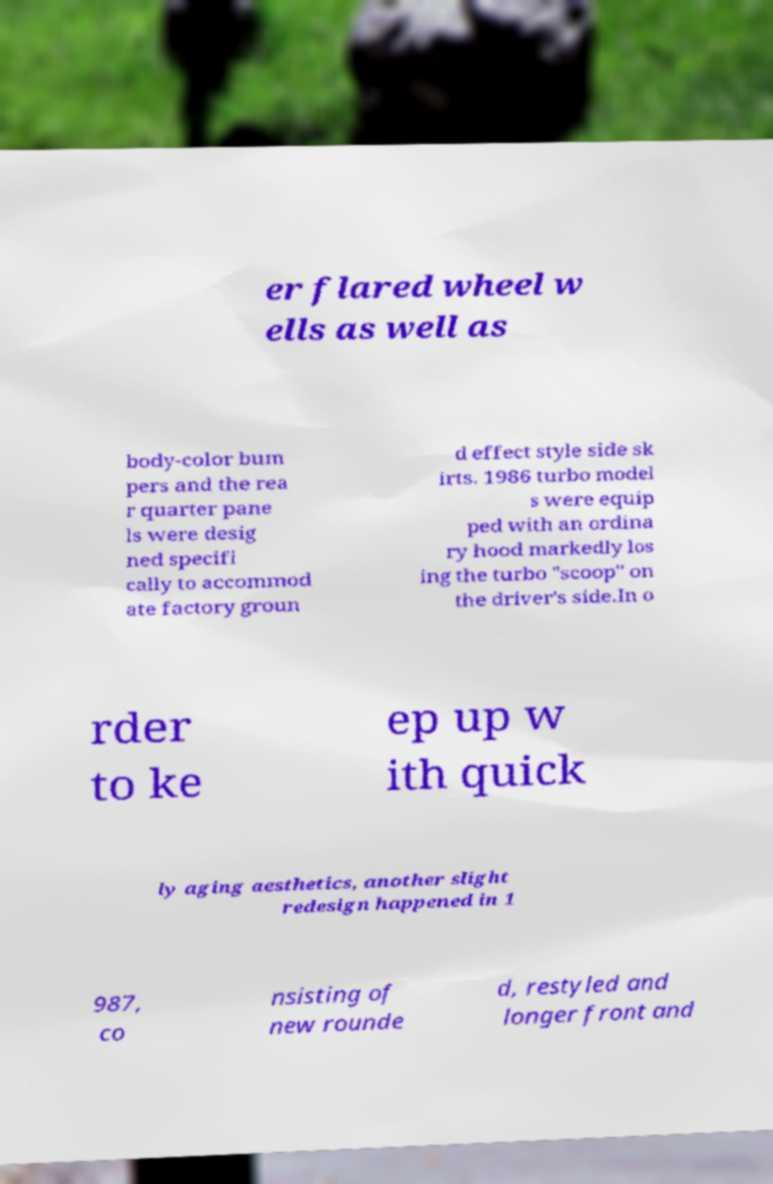I need the written content from this picture converted into text. Can you do that? er flared wheel w ells as well as body-color bum pers and the rea r quarter pane ls were desig ned specifi cally to accommod ate factory groun d effect style side sk irts. 1986 turbo model s were equip ped with an ordina ry hood markedly los ing the turbo "scoop" on the driver's side.In o rder to ke ep up w ith quick ly aging aesthetics, another slight redesign happened in 1 987, co nsisting of new rounde d, restyled and longer front and 